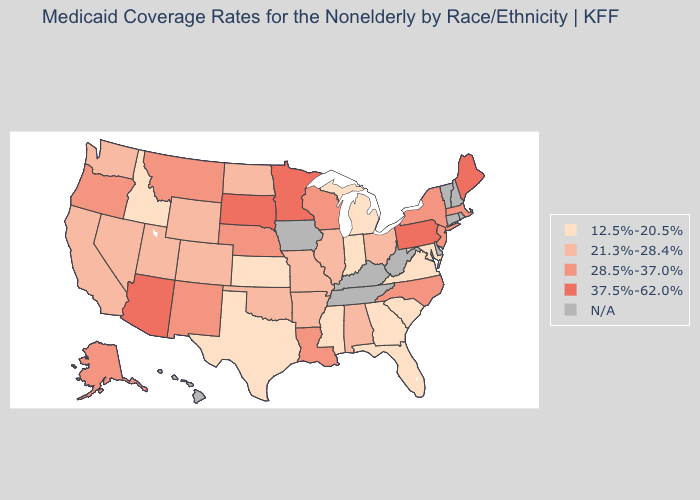What is the lowest value in states that border New Mexico?
Short answer required. 12.5%-20.5%. What is the highest value in the South ?
Quick response, please. 28.5%-37.0%. Does the map have missing data?
Give a very brief answer. Yes. What is the lowest value in the USA?
Be succinct. 12.5%-20.5%. Does the map have missing data?
Give a very brief answer. Yes. What is the value of West Virginia?
Quick response, please. N/A. Name the states that have a value in the range 12.5%-20.5%?
Keep it brief. Florida, Georgia, Idaho, Indiana, Kansas, Maryland, Michigan, Mississippi, South Carolina, Texas, Virginia. Name the states that have a value in the range N/A?
Short answer required. Connecticut, Delaware, Hawaii, Iowa, Kentucky, New Hampshire, Rhode Island, Tennessee, Vermont, West Virginia. Name the states that have a value in the range 37.5%-62.0%?
Short answer required. Arizona, Maine, Minnesota, Pennsylvania, South Dakota. What is the highest value in the West ?
Answer briefly. 37.5%-62.0%. Which states hav the highest value in the West?
Write a very short answer. Arizona. Name the states that have a value in the range 21.3%-28.4%?
Give a very brief answer. Alabama, Arkansas, California, Colorado, Illinois, Missouri, Nevada, North Dakota, Ohio, Oklahoma, Utah, Washington, Wyoming. Does Mississippi have the lowest value in the USA?
Write a very short answer. Yes. 